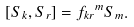<formula> <loc_0><loc_0><loc_500><loc_500>[ S _ { k } , S _ { r } ] = { f _ { k r } } ^ { m } S _ { m } .</formula> 